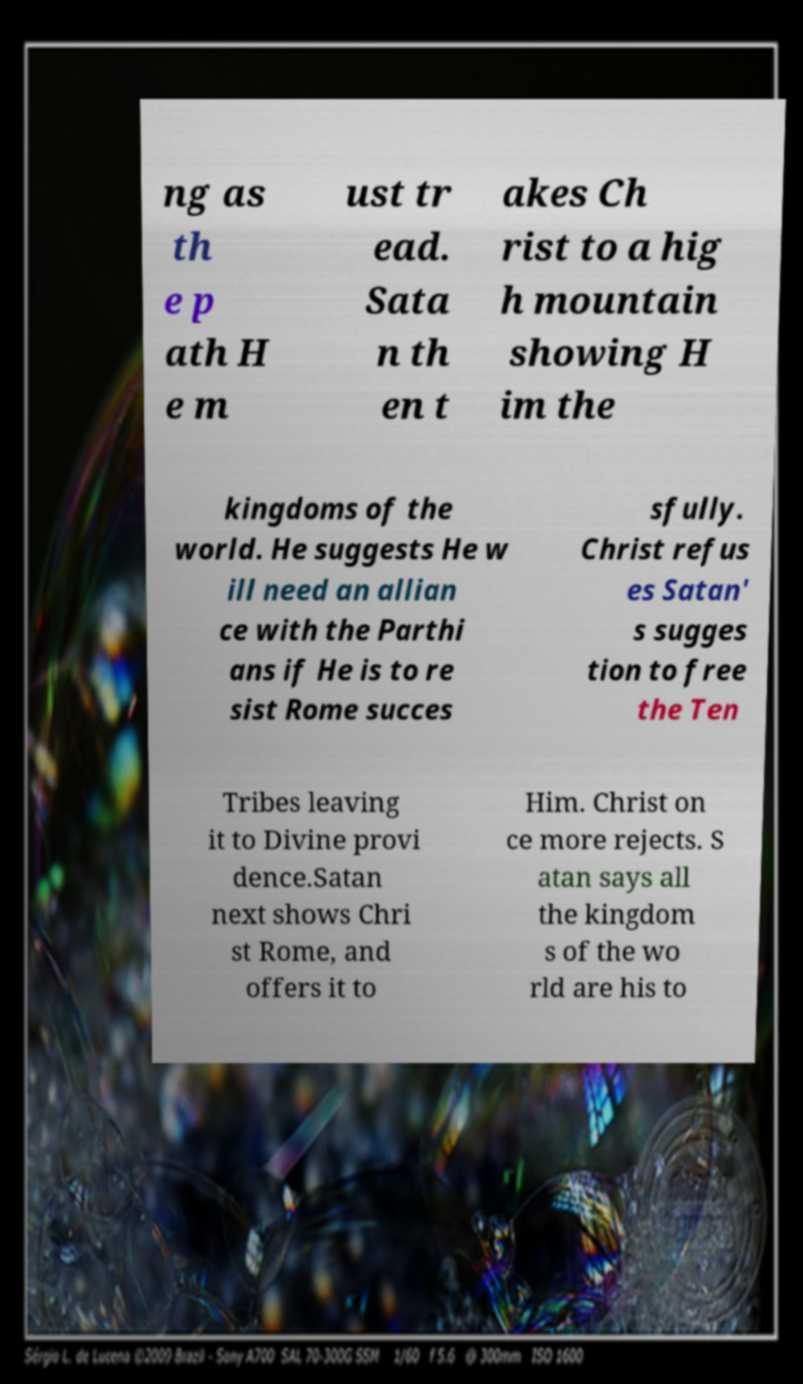Please read and relay the text visible in this image. What does it say? ng as th e p ath H e m ust tr ead. Sata n th en t akes Ch rist to a hig h mountain showing H im the kingdoms of the world. He suggests He w ill need an allian ce with the Parthi ans if He is to re sist Rome succes sfully. Christ refus es Satan' s sugges tion to free the Ten Tribes leaving it to Divine provi dence.Satan next shows Chri st Rome, and offers it to Him. Christ on ce more rejects. S atan says all the kingdom s of the wo rld are his to 